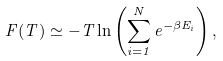Convert formula to latex. <formula><loc_0><loc_0><loc_500><loc_500>F ( T ) \simeq - T \ln \left ( \sum _ { i = 1 } ^ { N } e ^ { - \beta E _ { i } } \right ) ,</formula> 